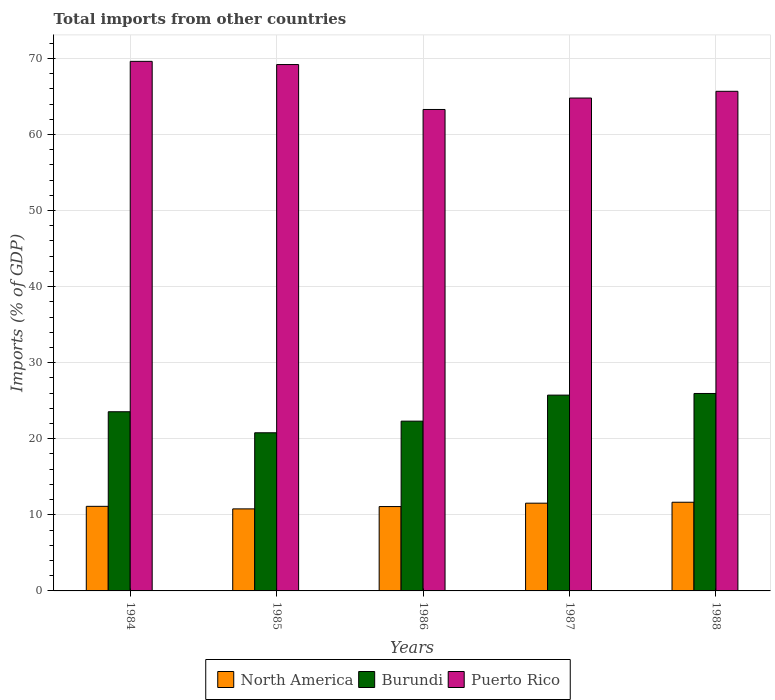Are the number of bars on each tick of the X-axis equal?
Keep it short and to the point. Yes. What is the total imports in Puerto Rico in 1988?
Offer a very short reply. 65.67. Across all years, what is the maximum total imports in Burundi?
Your answer should be very brief. 25.95. Across all years, what is the minimum total imports in North America?
Make the answer very short. 10.78. In which year was the total imports in Burundi maximum?
Keep it short and to the point. 1988. In which year was the total imports in Burundi minimum?
Offer a terse response. 1985. What is the total total imports in North America in the graph?
Offer a terse response. 56.18. What is the difference between the total imports in Burundi in 1984 and that in 1988?
Your response must be concise. -2.4. What is the difference between the total imports in North America in 1988 and the total imports in Puerto Rico in 1987?
Your answer should be compact. -53.13. What is the average total imports in Puerto Rico per year?
Keep it short and to the point. 66.51. In the year 1986, what is the difference between the total imports in Burundi and total imports in Puerto Rico?
Your answer should be compact. -40.97. In how many years, is the total imports in Puerto Rico greater than 28 %?
Your answer should be compact. 5. What is the ratio of the total imports in Puerto Rico in 1984 to that in 1987?
Make the answer very short. 1.07. Is the total imports in Puerto Rico in 1984 less than that in 1988?
Your response must be concise. No. Is the difference between the total imports in Burundi in 1986 and 1987 greater than the difference between the total imports in Puerto Rico in 1986 and 1987?
Ensure brevity in your answer.  No. What is the difference between the highest and the second highest total imports in Burundi?
Give a very brief answer. 0.21. What is the difference between the highest and the lowest total imports in Burundi?
Provide a succinct answer. 5.17. What does the 2nd bar from the left in 1988 represents?
Provide a succinct answer. Burundi. What does the 2nd bar from the right in 1988 represents?
Your answer should be very brief. Burundi. Is it the case that in every year, the sum of the total imports in Burundi and total imports in Puerto Rico is greater than the total imports in North America?
Offer a terse response. Yes. How many bars are there?
Make the answer very short. 15. Are all the bars in the graph horizontal?
Your answer should be very brief. No. How many years are there in the graph?
Offer a terse response. 5. Does the graph contain grids?
Keep it short and to the point. Yes. Where does the legend appear in the graph?
Offer a very short reply. Bottom center. How are the legend labels stacked?
Offer a terse response. Horizontal. What is the title of the graph?
Provide a short and direct response. Total imports from other countries. Does "European Union" appear as one of the legend labels in the graph?
Provide a short and direct response. No. What is the label or title of the X-axis?
Offer a terse response. Years. What is the label or title of the Y-axis?
Offer a terse response. Imports (% of GDP). What is the Imports (% of GDP) of North America in 1984?
Offer a terse response. 11.12. What is the Imports (% of GDP) in Burundi in 1984?
Provide a succinct answer. 23.55. What is the Imports (% of GDP) of Puerto Rico in 1984?
Your response must be concise. 69.61. What is the Imports (% of GDP) in North America in 1985?
Make the answer very short. 10.78. What is the Imports (% of GDP) of Burundi in 1985?
Provide a short and direct response. 20.79. What is the Imports (% of GDP) in Puerto Rico in 1985?
Give a very brief answer. 69.19. What is the Imports (% of GDP) of North America in 1986?
Your answer should be very brief. 11.09. What is the Imports (% of GDP) in Burundi in 1986?
Ensure brevity in your answer.  22.32. What is the Imports (% of GDP) of Puerto Rico in 1986?
Ensure brevity in your answer.  63.28. What is the Imports (% of GDP) of North America in 1987?
Ensure brevity in your answer.  11.53. What is the Imports (% of GDP) of Burundi in 1987?
Offer a terse response. 25.74. What is the Imports (% of GDP) in Puerto Rico in 1987?
Keep it short and to the point. 64.79. What is the Imports (% of GDP) of North America in 1988?
Offer a very short reply. 11.66. What is the Imports (% of GDP) of Burundi in 1988?
Offer a terse response. 25.95. What is the Imports (% of GDP) of Puerto Rico in 1988?
Your response must be concise. 65.67. Across all years, what is the maximum Imports (% of GDP) in North America?
Offer a very short reply. 11.66. Across all years, what is the maximum Imports (% of GDP) in Burundi?
Make the answer very short. 25.95. Across all years, what is the maximum Imports (% of GDP) of Puerto Rico?
Ensure brevity in your answer.  69.61. Across all years, what is the minimum Imports (% of GDP) in North America?
Provide a succinct answer. 10.78. Across all years, what is the minimum Imports (% of GDP) of Burundi?
Your response must be concise. 20.79. Across all years, what is the minimum Imports (% of GDP) of Puerto Rico?
Provide a short and direct response. 63.28. What is the total Imports (% of GDP) of North America in the graph?
Offer a very short reply. 56.18. What is the total Imports (% of GDP) of Burundi in the graph?
Your answer should be compact. 118.35. What is the total Imports (% of GDP) of Puerto Rico in the graph?
Give a very brief answer. 332.54. What is the difference between the Imports (% of GDP) in North America in 1984 and that in 1985?
Your response must be concise. 0.33. What is the difference between the Imports (% of GDP) in Burundi in 1984 and that in 1985?
Provide a succinct answer. 2.77. What is the difference between the Imports (% of GDP) in Puerto Rico in 1984 and that in 1985?
Keep it short and to the point. 0.42. What is the difference between the Imports (% of GDP) in North America in 1984 and that in 1986?
Provide a short and direct response. 0.03. What is the difference between the Imports (% of GDP) in Burundi in 1984 and that in 1986?
Your answer should be very brief. 1.24. What is the difference between the Imports (% of GDP) of Puerto Rico in 1984 and that in 1986?
Ensure brevity in your answer.  6.33. What is the difference between the Imports (% of GDP) of North America in 1984 and that in 1987?
Offer a very short reply. -0.42. What is the difference between the Imports (% of GDP) in Burundi in 1984 and that in 1987?
Keep it short and to the point. -2.19. What is the difference between the Imports (% of GDP) of Puerto Rico in 1984 and that in 1987?
Keep it short and to the point. 4.82. What is the difference between the Imports (% of GDP) of North America in 1984 and that in 1988?
Your response must be concise. -0.54. What is the difference between the Imports (% of GDP) of Burundi in 1984 and that in 1988?
Your answer should be very brief. -2.4. What is the difference between the Imports (% of GDP) in Puerto Rico in 1984 and that in 1988?
Offer a very short reply. 3.94. What is the difference between the Imports (% of GDP) in North America in 1985 and that in 1986?
Offer a terse response. -0.31. What is the difference between the Imports (% of GDP) of Burundi in 1985 and that in 1986?
Your response must be concise. -1.53. What is the difference between the Imports (% of GDP) of Puerto Rico in 1985 and that in 1986?
Offer a terse response. 5.91. What is the difference between the Imports (% of GDP) in North America in 1985 and that in 1987?
Provide a succinct answer. -0.75. What is the difference between the Imports (% of GDP) in Burundi in 1985 and that in 1987?
Your response must be concise. -4.95. What is the difference between the Imports (% of GDP) of Puerto Rico in 1985 and that in 1987?
Your answer should be compact. 4.4. What is the difference between the Imports (% of GDP) in North America in 1985 and that in 1988?
Offer a very short reply. -0.87. What is the difference between the Imports (% of GDP) of Burundi in 1985 and that in 1988?
Your answer should be very brief. -5.17. What is the difference between the Imports (% of GDP) in Puerto Rico in 1985 and that in 1988?
Offer a very short reply. 3.52. What is the difference between the Imports (% of GDP) of North America in 1986 and that in 1987?
Give a very brief answer. -0.45. What is the difference between the Imports (% of GDP) of Burundi in 1986 and that in 1987?
Provide a succinct answer. -3.42. What is the difference between the Imports (% of GDP) of Puerto Rico in 1986 and that in 1987?
Your response must be concise. -1.5. What is the difference between the Imports (% of GDP) of North America in 1986 and that in 1988?
Your answer should be compact. -0.57. What is the difference between the Imports (% of GDP) in Burundi in 1986 and that in 1988?
Your response must be concise. -3.64. What is the difference between the Imports (% of GDP) in Puerto Rico in 1986 and that in 1988?
Ensure brevity in your answer.  -2.39. What is the difference between the Imports (% of GDP) in North America in 1987 and that in 1988?
Ensure brevity in your answer.  -0.12. What is the difference between the Imports (% of GDP) in Burundi in 1987 and that in 1988?
Your response must be concise. -0.21. What is the difference between the Imports (% of GDP) in Puerto Rico in 1987 and that in 1988?
Make the answer very short. -0.88. What is the difference between the Imports (% of GDP) in North America in 1984 and the Imports (% of GDP) in Burundi in 1985?
Ensure brevity in your answer.  -9.67. What is the difference between the Imports (% of GDP) of North America in 1984 and the Imports (% of GDP) of Puerto Rico in 1985?
Provide a succinct answer. -58.07. What is the difference between the Imports (% of GDP) of Burundi in 1984 and the Imports (% of GDP) of Puerto Rico in 1985?
Your response must be concise. -45.64. What is the difference between the Imports (% of GDP) of North America in 1984 and the Imports (% of GDP) of Burundi in 1986?
Make the answer very short. -11.2. What is the difference between the Imports (% of GDP) of North America in 1984 and the Imports (% of GDP) of Puerto Rico in 1986?
Offer a terse response. -52.17. What is the difference between the Imports (% of GDP) of Burundi in 1984 and the Imports (% of GDP) of Puerto Rico in 1986?
Ensure brevity in your answer.  -39.73. What is the difference between the Imports (% of GDP) of North America in 1984 and the Imports (% of GDP) of Burundi in 1987?
Your answer should be very brief. -14.62. What is the difference between the Imports (% of GDP) of North America in 1984 and the Imports (% of GDP) of Puerto Rico in 1987?
Your answer should be compact. -53.67. What is the difference between the Imports (% of GDP) of Burundi in 1984 and the Imports (% of GDP) of Puerto Rico in 1987?
Provide a short and direct response. -41.24. What is the difference between the Imports (% of GDP) of North America in 1984 and the Imports (% of GDP) of Burundi in 1988?
Keep it short and to the point. -14.84. What is the difference between the Imports (% of GDP) in North America in 1984 and the Imports (% of GDP) in Puerto Rico in 1988?
Your response must be concise. -54.55. What is the difference between the Imports (% of GDP) of Burundi in 1984 and the Imports (% of GDP) of Puerto Rico in 1988?
Give a very brief answer. -42.12. What is the difference between the Imports (% of GDP) of North America in 1985 and the Imports (% of GDP) of Burundi in 1986?
Ensure brevity in your answer.  -11.53. What is the difference between the Imports (% of GDP) in North America in 1985 and the Imports (% of GDP) in Puerto Rico in 1986?
Your answer should be very brief. -52.5. What is the difference between the Imports (% of GDP) in Burundi in 1985 and the Imports (% of GDP) in Puerto Rico in 1986?
Ensure brevity in your answer.  -42.5. What is the difference between the Imports (% of GDP) in North America in 1985 and the Imports (% of GDP) in Burundi in 1987?
Offer a terse response. -14.96. What is the difference between the Imports (% of GDP) in North America in 1985 and the Imports (% of GDP) in Puerto Rico in 1987?
Your response must be concise. -54. What is the difference between the Imports (% of GDP) in Burundi in 1985 and the Imports (% of GDP) in Puerto Rico in 1987?
Ensure brevity in your answer.  -44. What is the difference between the Imports (% of GDP) of North America in 1985 and the Imports (% of GDP) of Burundi in 1988?
Your answer should be very brief. -15.17. What is the difference between the Imports (% of GDP) in North America in 1985 and the Imports (% of GDP) in Puerto Rico in 1988?
Your answer should be very brief. -54.89. What is the difference between the Imports (% of GDP) of Burundi in 1985 and the Imports (% of GDP) of Puerto Rico in 1988?
Provide a succinct answer. -44.89. What is the difference between the Imports (% of GDP) of North America in 1986 and the Imports (% of GDP) of Burundi in 1987?
Offer a very short reply. -14.65. What is the difference between the Imports (% of GDP) of North America in 1986 and the Imports (% of GDP) of Puerto Rico in 1987?
Provide a short and direct response. -53.7. What is the difference between the Imports (% of GDP) of Burundi in 1986 and the Imports (% of GDP) of Puerto Rico in 1987?
Offer a very short reply. -42.47. What is the difference between the Imports (% of GDP) in North America in 1986 and the Imports (% of GDP) in Burundi in 1988?
Keep it short and to the point. -14.86. What is the difference between the Imports (% of GDP) of North America in 1986 and the Imports (% of GDP) of Puerto Rico in 1988?
Offer a very short reply. -54.58. What is the difference between the Imports (% of GDP) of Burundi in 1986 and the Imports (% of GDP) of Puerto Rico in 1988?
Offer a terse response. -43.36. What is the difference between the Imports (% of GDP) in North America in 1987 and the Imports (% of GDP) in Burundi in 1988?
Give a very brief answer. -14.42. What is the difference between the Imports (% of GDP) of North America in 1987 and the Imports (% of GDP) of Puerto Rico in 1988?
Your answer should be very brief. -54.14. What is the difference between the Imports (% of GDP) of Burundi in 1987 and the Imports (% of GDP) of Puerto Rico in 1988?
Make the answer very short. -39.93. What is the average Imports (% of GDP) of North America per year?
Your answer should be very brief. 11.24. What is the average Imports (% of GDP) in Burundi per year?
Keep it short and to the point. 23.67. What is the average Imports (% of GDP) of Puerto Rico per year?
Your response must be concise. 66.51. In the year 1984, what is the difference between the Imports (% of GDP) of North America and Imports (% of GDP) of Burundi?
Your answer should be compact. -12.43. In the year 1984, what is the difference between the Imports (% of GDP) in North America and Imports (% of GDP) in Puerto Rico?
Give a very brief answer. -58.49. In the year 1984, what is the difference between the Imports (% of GDP) in Burundi and Imports (% of GDP) in Puerto Rico?
Provide a short and direct response. -46.06. In the year 1985, what is the difference between the Imports (% of GDP) in North America and Imports (% of GDP) in Burundi?
Ensure brevity in your answer.  -10. In the year 1985, what is the difference between the Imports (% of GDP) in North America and Imports (% of GDP) in Puerto Rico?
Your answer should be compact. -58.41. In the year 1985, what is the difference between the Imports (% of GDP) in Burundi and Imports (% of GDP) in Puerto Rico?
Your response must be concise. -48.4. In the year 1986, what is the difference between the Imports (% of GDP) of North America and Imports (% of GDP) of Burundi?
Offer a terse response. -11.23. In the year 1986, what is the difference between the Imports (% of GDP) in North America and Imports (% of GDP) in Puerto Rico?
Give a very brief answer. -52.19. In the year 1986, what is the difference between the Imports (% of GDP) in Burundi and Imports (% of GDP) in Puerto Rico?
Offer a very short reply. -40.97. In the year 1987, what is the difference between the Imports (% of GDP) in North America and Imports (% of GDP) in Burundi?
Ensure brevity in your answer.  -14.2. In the year 1987, what is the difference between the Imports (% of GDP) of North America and Imports (% of GDP) of Puerto Rico?
Give a very brief answer. -53.25. In the year 1987, what is the difference between the Imports (% of GDP) in Burundi and Imports (% of GDP) in Puerto Rico?
Offer a terse response. -39.05. In the year 1988, what is the difference between the Imports (% of GDP) in North America and Imports (% of GDP) in Burundi?
Give a very brief answer. -14.3. In the year 1988, what is the difference between the Imports (% of GDP) in North America and Imports (% of GDP) in Puerto Rico?
Your answer should be very brief. -54.02. In the year 1988, what is the difference between the Imports (% of GDP) of Burundi and Imports (% of GDP) of Puerto Rico?
Ensure brevity in your answer.  -39.72. What is the ratio of the Imports (% of GDP) of North America in 1984 to that in 1985?
Give a very brief answer. 1.03. What is the ratio of the Imports (% of GDP) in Burundi in 1984 to that in 1985?
Give a very brief answer. 1.13. What is the ratio of the Imports (% of GDP) in Puerto Rico in 1984 to that in 1985?
Ensure brevity in your answer.  1.01. What is the ratio of the Imports (% of GDP) in Burundi in 1984 to that in 1986?
Give a very brief answer. 1.06. What is the ratio of the Imports (% of GDP) of Puerto Rico in 1984 to that in 1986?
Make the answer very short. 1.1. What is the ratio of the Imports (% of GDP) of North America in 1984 to that in 1987?
Make the answer very short. 0.96. What is the ratio of the Imports (% of GDP) in Burundi in 1984 to that in 1987?
Your answer should be very brief. 0.92. What is the ratio of the Imports (% of GDP) in Puerto Rico in 1984 to that in 1987?
Offer a very short reply. 1.07. What is the ratio of the Imports (% of GDP) in North America in 1984 to that in 1988?
Give a very brief answer. 0.95. What is the ratio of the Imports (% of GDP) in Burundi in 1984 to that in 1988?
Offer a very short reply. 0.91. What is the ratio of the Imports (% of GDP) of Puerto Rico in 1984 to that in 1988?
Make the answer very short. 1.06. What is the ratio of the Imports (% of GDP) in North America in 1985 to that in 1986?
Provide a short and direct response. 0.97. What is the ratio of the Imports (% of GDP) in Burundi in 1985 to that in 1986?
Your response must be concise. 0.93. What is the ratio of the Imports (% of GDP) of Puerto Rico in 1985 to that in 1986?
Provide a short and direct response. 1.09. What is the ratio of the Imports (% of GDP) in North America in 1985 to that in 1987?
Your response must be concise. 0.93. What is the ratio of the Imports (% of GDP) in Burundi in 1985 to that in 1987?
Make the answer very short. 0.81. What is the ratio of the Imports (% of GDP) in Puerto Rico in 1985 to that in 1987?
Keep it short and to the point. 1.07. What is the ratio of the Imports (% of GDP) of North America in 1985 to that in 1988?
Offer a very short reply. 0.93. What is the ratio of the Imports (% of GDP) of Burundi in 1985 to that in 1988?
Your answer should be compact. 0.8. What is the ratio of the Imports (% of GDP) of Puerto Rico in 1985 to that in 1988?
Offer a very short reply. 1.05. What is the ratio of the Imports (% of GDP) of North America in 1986 to that in 1987?
Provide a succinct answer. 0.96. What is the ratio of the Imports (% of GDP) in Burundi in 1986 to that in 1987?
Provide a succinct answer. 0.87. What is the ratio of the Imports (% of GDP) of Puerto Rico in 1986 to that in 1987?
Give a very brief answer. 0.98. What is the ratio of the Imports (% of GDP) in North America in 1986 to that in 1988?
Your answer should be compact. 0.95. What is the ratio of the Imports (% of GDP) in Burundi in 1986 to that in 1988?
Give a very brief answer. 0.86. What is the ratio of the Imports (% of GDP) of Puerto Rico in 1986 to that in 1988?
Your answer should be compact. 0.96. What is the ratio of the Imports (% of GDP) of North America in 1987 to that in 1988?
Provide a short and direct response. 0.99. What is the ratio of the Imports (% of GDP) of Burundi in 1987 to that in 1988?
Offer a terse response. 0.99. What is the ratio of the Imports (% of GDP) of Puerto Rico in 1987 to that in 1988?
Your response must be concise. 0.99. What is the difference between the highest and the second highest Imports (% of GDP) of North America?
Keep it short and to the point. 0.12. What is the difference between the highest and the second highest Imports (% of GDP) of Burundi?
Keep it short and to the point. 0.21. What is the difference between the highest and the second highest Imports (% of GDP) of Puerto Rico?
Your answer should be very brief. 0.42. What is the difference between the highest and the lowest Imports (% of GDP) of North America?
Offer a very short reply. 0.87. What is the difference between the highest and the lowest Imports (% of GDP) of Burundi?
Provide a succinct answer. 5.17. What is the difference between the highest and the lowest Imports (% of GDP) of Puerto Rico?
Provide a short and direct response. 6.33. 